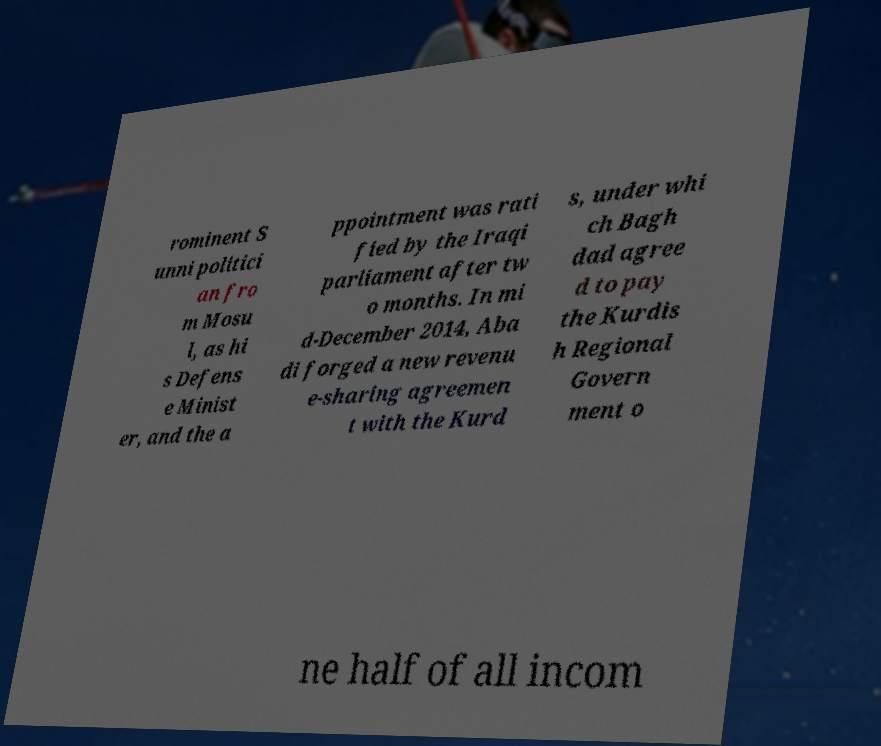Could you extract and type out the text from this image? rominent S unni politici an fro m Mosu l, as hi s Defens e Minist er, and the a ppointment was rati fied by the Iraqi parliament after tw o months. In mi d-December 2014, Aba di forged a new revenu e-sharing agreemen t with the Kurd s, under whi ch Bagh dad agree d to pay the Kurdis h Regional Govern ment o ne half of all incom 